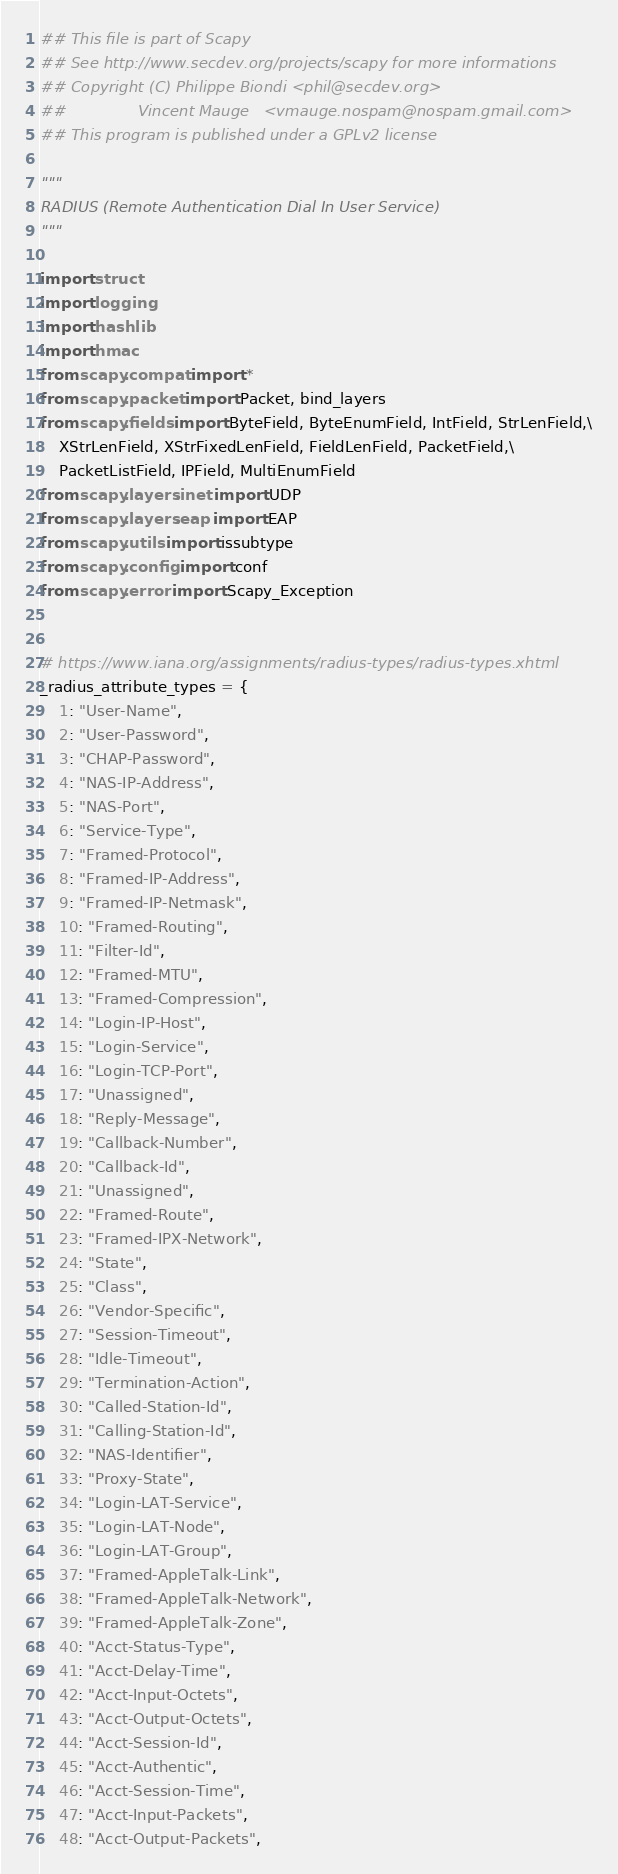Convert code to text. <code><loc_0><loc_0><loc_500><loc_500><_Python_>## This file is part of Scapy
## See http://www.secdev.org/projects/scapy for more informations
## Copyright (C) Philippe Biondi <phil@secdev.org>
##               Vincent Mauge   <vmauge.nospam@nospam.gmail.com>
## This program is published under a GPLv2 license

"""
RADIUS (Remote Authentication Dial In User Service)
"""

import struct
import logging
import hashlib
import hmac
from scapy.compat import *
from scapy.packet import Packet, bind_layers
from scapy.fields import ByteField, ByteEnumField, IntField, StrLenField,\
    XStrLenField, XStrFixedLenField, FieldLenField, PacketField,\
    PacketListField, IPField, MultiEnumField
from scapy.layers.inet import UDP
from scapy.layers.eap import EAP
from scapy.utils import issubtype
from scapy.config import conf
from scapy.error import Scapy_Exception


# https://www.iana.org/assignments/radius-types/radius-types.xhtml
_radius_attribute_types = {
    1: "User-Name",
    2: "User-Password",
    3: "CHAP-Password",
    4: "NAS-IP-Address",
    5: "NAS-Port",
    6: "Service-Type",
    7: "Framed-Protocol",
    8: "Framed-IP-Address",
    9: "Framed-IP-Netmask",
    10: "Framed-Routing",
    11: "Filter-Id",
    12: "Framed-MTU",
    13: "Framed-Compression",
    14: "Login-IP-Host",
    15: "Login-Service",
    16: "Login-TCP-Port",
    17: "Unassigned",
    18: "Reply-Message",
    19: "Callback-Number",
    20: "Callback-Id",
    21: "Unassigned",
    22: "Framed-Route",
    23: "Framed-IPX-Network",
    24: "State",
    25: "Class",
    26: "Vendor-Specific",
    27: "Session-Timeout",
    28: "Idle-Timeout",
    29: "Termination-Action",
    30: "Called-Station-Id",
    31: "Calling-Station-Id",
    32: "NAS-Identifier",
    33: "Proxy-State",
    34: "Login-LAT-Service",
    35: "Login-LAT-Node",
    36: "Login-LAT-Group",
    37: "Framed-AppleTalk-Link",
    38: "Framed-AppleTalk-Network",
    39: "Framed-AppleTalk-Zone",
    40: "Acct-Status-Type",
    41: "Acct-Delay-Time",
    42: "Acct-Input-Octets",
    43: "Acct-Output-Octets",
    44: "Acct-Session-Id",
    45: "Acct-Authentic",
    46: "Acct-Session-Time",
    47: "Acct-Input-Packets",
    48: "Acct-Output-Packets",</code> 